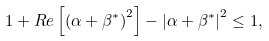<formula> <loc_0><loc_0><loc_500><loc_500>1 + R e \left [ \left ( \alpha + \beta ^ { \ast } \right ) ^ { 2 } \right ] - \left | \alpha + \beta ^ { \ast } \right | ^ { 2 } \leq 1 ,</formula> 